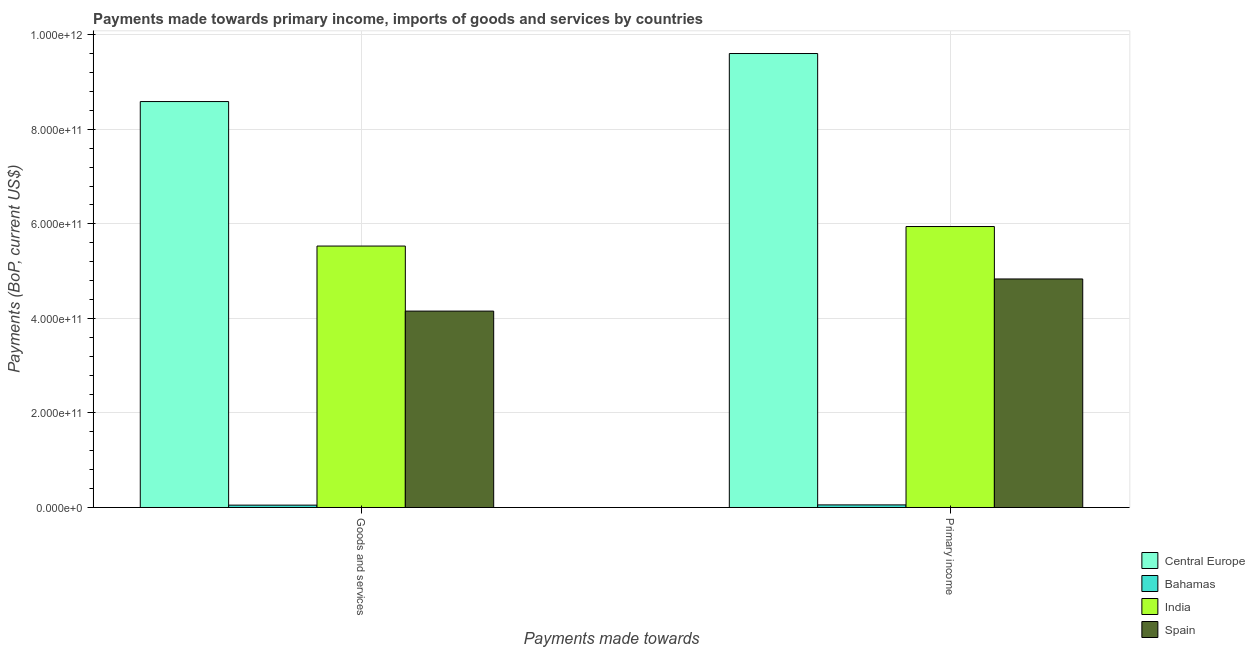How many groups of bars are there?
Keep it short and to the point. 2. How many bars are there on the 2nd tick from the right?
Provide a succinct answer. 4. What is the label of the 1st group of bars from the left?
Keep it short and to the point. Goods and services. What is the payments made towards primary income in Central Europe?
Make the answer very short. 9.60e+11. Across all countries, what is the maximum payments made towards primary income?
Make the answer very short. 9.60e+11. Across all countries, what is the minimum payments made towards goods and services?
Make the answer very short. 4.99e+09. In which country was the payments made towards primary income maximum?
Ensure brevity in your answer.  Central Europe. In which country was the payments made towards primary income minimum?
Ensure brevity in your answer.  Bahamas. What is the total payments made towards goods and services in the graph?
Keep it short and to the point. 1.83e+12. What is the difference between the payments made towards goods and services in Bahamas and that in Spain?
Ensure brevity in your answer.  -4.10e+11. What is the difference between the payments made towards primary income in Spain and the payments made towards goods and services in Central Europe?
Make the answer very short. -3.75e+11. What is the average payments made towards primary income per country?
Provide a short and direct response. 5.11e+11. What is the difference between the payments made towards primary income and payments made towards goods and services in India?
Your response must be concise. 4.13e+1. In how many countries, is the payments made towards goods and services greater than 720000000000 US$?
Your answer should be very brief. 1. What is the ratio of the payments made towards goods and services in Bahamas to that in India?
Your answer should be very brief. 0.01. Is the payments made towards goods and services in India less than that in Spain?
Ensure brevity in your answer.  No. What does the 1st bar from the left in Primary income represents?
Provide a succinct answer. Central Europe. What does the 4th bar from the right in Primary income represents?
Ensure brevity in your answer.  Central Europe. What is the difference between two consecutive major ticks on the Y-axis?
Your response must be concise. 2.00e+11. Does the graph contain any zero values?
Provide a succinct answer. No. How many legend labels are there?
Offer a very short reply. 4. How are the legend labels stacked?
Your answer should be compact. Vertical. What is the title of the graph?
Offer a very short reply. Payments made towards primary income, imports of goods and services by countries. Does "Least developed countries" appear as one of the legend labels in the graph?
Give a very brief answer. No. What is the label or title of the X-axis?
Offer a terse response. Payments made towards. What is the label or title of the Y-axis?
Your answer should be compact. Payments (BoP, current US$). What is the Payments (BoP, current US$) in Central Europe in Goods and services?
Your response must be concise. 8.59e+11. What is the Payments (BoP, current US$) of Bahamas in Goods and services?
Give a very brief answer. 4.99e+09. What is the Payments (BoP, current US$) in India in Goods and services?
Ensure brevity in your answer.  5.53e+11. What is the Payments (BoP, current US$) of Spain in Goods and services?
Ensure brevity in your answer.  4.15e+11. What is the Payments (BoP, current US$) of Central Europe in Primary income?
Give a very brief answer. 9.60e+11. What is the Payments (BoP, current US$) of Bahamas in Primary income?
Give a very brief answer. 5.48e+09. What is the Payments (BoP, current US$) in India in Primary income?
Your answer should be very brief. 5.94e+11. What is the Payments (BoP, current US$) in Spain in Primary income?
Ensure brevity in your answer.  4.83e+11. Across all Payments made towards, what is the maximum Payments (BoP, current US$) of Central Europe?
Your answer should be very brief. 9.60e+11. Across all Payments made towards, what is the maximum Payments (BoP, current US$) in Bahamas?
Provide a succinct answer. 5.48e+09. Across all Payments made towards, what is the maximum Payments (BoP, current US$) in India?
Provide a succinct answer. 5.94e+11. Across all Payments made towards, what is the maximum Payments (BoP, current US$) in Spain?
Keep it short and to the point. 4.83e+11. Across all Payments made towards, what is the minimum Payments (BoP, current US$) in Central Europe?
Keep it short and to the point. 8.59e+11. Across all Payments made towards, what is the minimum Payments (BoP, current US$) of Bahamas?
Your answer should be compact. 4.99e+09. Across all Payments made towards, what is the minimum Payments (BoP, current US$) of India?
Your response must be concise. 5.53e+11. Across all Payments made towards, what is the minimum Payments (BoP, current US$) in Spain?
Offer a terse response. 4.15e+11. What is the total Payments (BoP, current US$) in Central Europe in the graph?
Keep it short and to the point. 1.82e+12. What is the total Payments (BoP, current US$) in Bahamas in the graph?
Your answer should be very brief. 1.05e+1. What is the total Payments (BoP, current US$) in India in the graph?
Offer a very short reply. 1.15e+12. What is the total Payments (BoP, current US$) in Spain in the graph?
Provide a short and direct response. 8.99e+11. What is the difference between the Payments (BoP, current US$) of Central Europe in Goods and services and that in Primary income?
Offer a terse response. -1.02e+11. What is the difference between the Payments (BoP, current US$) in Bahamas in Goods and services and that in Primary income?
Make the answer very short. -4.92e+08. What is the difference between the Payments (BoP, current US$) in India in Goods and services and that in Primary income?
Keep it short and to the point. -4.13e+1. What is the difference between the Payments (BoP, current US$) in Spain in Goods and services and that in Primary income?
Your response must be concise. -6.80e+1. What is the difference between the Payments (BoP, current US$) of Central Europe in Goods and services and the Payments (BoP, current US$) of Bahamas in Primary income?
Keep it short and to the point. 8.53e+11. What is the difference between the Payments (BoP, current US$) in Central Europe in Goods and services and the Payments (BoP, current US$) in India in Primary income?
Make the answer very short. 2.64e+11. What is the difference between the Payments (BoP, current US$) of Central Europe in Goods and services and the Payments (BoP, current US$) of Spain in Primary income?
Your response must be concise. 3.75e+11. What is the difference between the Payments (BoP, current US$) in Bahamas in Goods and services and the Payments (BoP, current US$) in India in Primary income?
Your answer should be very brief. -5.89e+11. What is the difference between the Payments (BoP, current US$) of Bahamas in Goods and services and the Payments (BoP, current US$) of Spain in Primary income?
Your answer should be compact. -4.78e+11. What is the difference between the Payments (BoP, current US$) of India in Goods and services and the Payments (BoP, current US$) of Spain in Primary income?
Provide a short and direct response. 6.96e+1. What is the average Payments (BoP, current US$) in Central Europe per Payments made towards?
Ensure brevity in your answer.  9.09e+11. What is the average Payments (BoP, current US$) in Bahamas per Payments made towards?
Your answer should be compact. 5.24e+09. What is the average Payments (BoP, current US$) of India per Payments made towards?
Offer a very short reply. 5.74e+11. What is the average Payments (BoP, current US$) in Spain per Payments made towards?
Your answer should be compact. 4.49e+11. What is the difference between the Payments (BoP, current US$) in Central Europe and Payments (BoP, current US$) in Bahamas in Goods and services?
Give a very brief answer. 8.54e+11. What is the difference between the Payments (BoP, current US$) of Central Europe and Payments (BoP, current US$) of India in Goods and services?
Provide a short and direct response. 3.06e+11. What is the difference between the Payments (BoP, current US$) in Central Europe and Payments (BoP, current US$) in Spain in Goods and services?
Make the answer very short. 4.43e+11. What is the difference between the Payments (BoP, current US$) in Bahamas and Payments (BoP, current US$) in India in Goods and services?
Your response must be concise. -5.48e+11. What is the difference between the Payments (BoP, current US$) in Bahamas and Payments (BoP, current US$) in Spain in Goods and services?
Your response must be concise. -4.10e+11. What is the difference between the Payments (BoP, current US$) of India and Payments (BoP, current US$) of Spain in Goods and services?
Make the answer very short. 1.38e+11. What is the difference between the Payments (BoP, current US$) of Central Europe and Payments (BoP, current US$) of Bahamas in Primary income?
Make the answer very short. 9.55e+11. What is the difference between the Payments (BoP, current US$) in Central Europe and Payments (BoP, current US$) in India in Primary income?
Give a very brief answer. 3.66e+11. What is the difference between the Payments (BoP, current US$) of Central Europe and Payments (BoP, current US$) of Spain in Primary income?
Offer a terse response. 4.77e+11. What is the difference between the Payments (BoP, current US$) of Bahamas and Payments (BoP, current US$) of India in Primary income?
Provide a short and direct response. -5.89e+11. What is the difference between the Payments (BoP, current US$) of Bahamas and Payments (BoP, current US$) of Spain in Primary income?
Your answer should be compact. -4.78e+11. What is the difference between the Payments (BoP, current US$) of India and Payments (BoP, current US$) of Spain in Primary income?
Your answer should be compact. 1.11e+11. What is the ratio of the Payments (BoP, current US$) in Central Europe in Goods and services to that in Primary income?
Provide a succinct answer. 0.89. What is the ratio of the Payments (BoP, current US$) in Bahamas in Goods and services to that in Primary income?
Provide a succinct answer. 0.91. What is the ratio of the Payments (BoP, current US$) in India in Goods and services to that in Primary income?
Provide a short and direct response. 0.93. What is the ratio of the Payments (BoP, current US$) in Spain in Goods and services to that in Primary income?
Make the answer very short. 0.86. What is the difference between the highest and the second highest Payments (BoP, current US$) of Central Europe?
Your response must be concise. 1.02e+11. What is the difference between the highest and the second highest Payments (BoP, current US$) of Bahamas?
Ensure brevity in your answer.  4.92e+08. What is the difference between the highest and the second highest Payments (BoP, current US$) in India?
Your answer should be compact. 4.13e+1. What is the difference between the highest and the second highest Payments (BoP, current US$) in Spain?
Offer a terse response. 6.80e+1. What is the difference between the highest and the lowest Payments (BoP, current US$) in Central Europe?
Your response must be concise. 1.02e+11. What is the difference between the highest and the lowest Payments (BoP, current US$) in Bahamas?
Provide a short and direct response. 4.92e+08. What is the difference between the highest and the lowest Payments (BoP, current US$) in India?
Make the answer very short. 4.13e+1. What is the difference between the highest and the lowest Payments (BoP, current US$) of Spain?
Make the answer very short. 6.80e+1. 